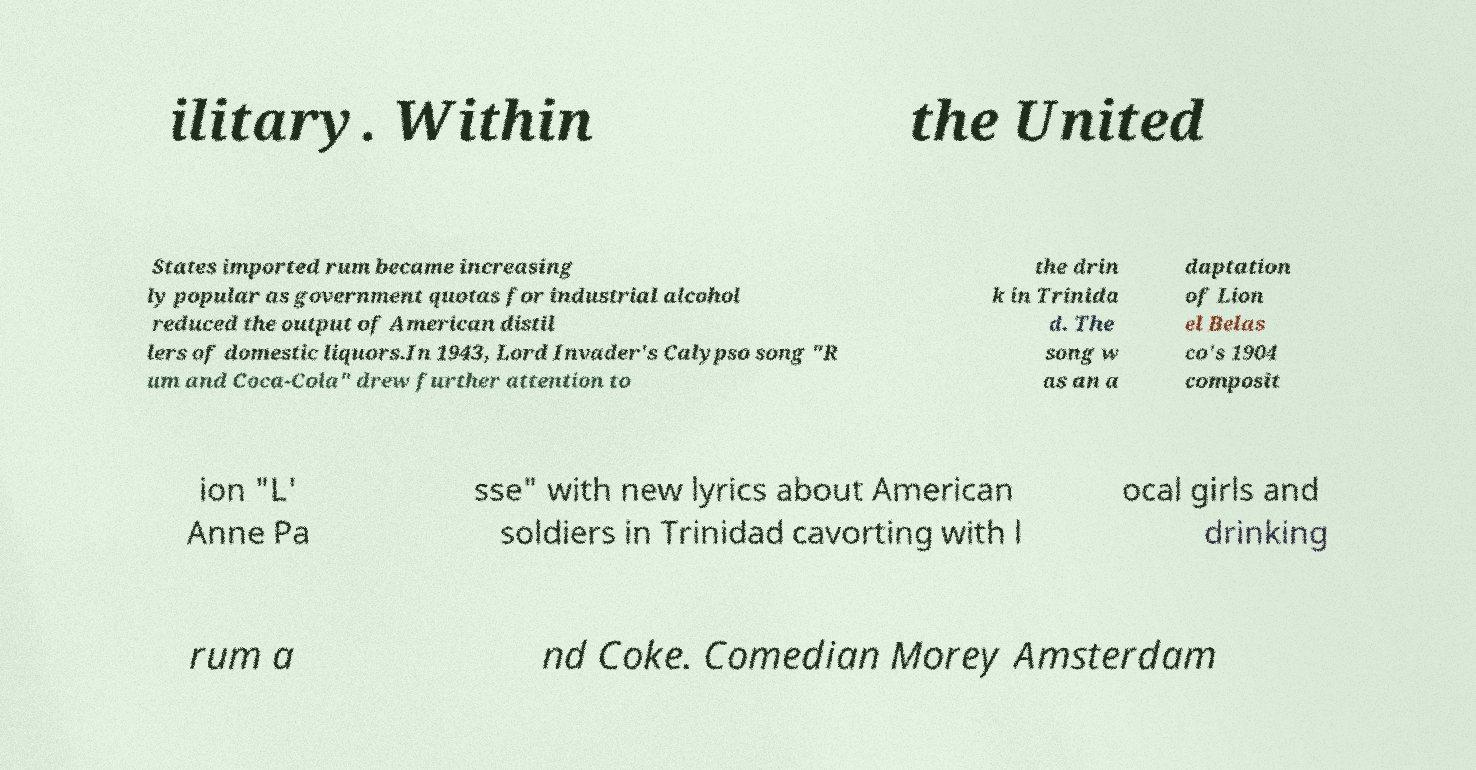Could you extract and type out the text from this image? ilitary. Within the United States imported rum became increasing ly popular as government quotas for industrial alcohol reduced the output of American distil lers of domestic liquors.In 1943, Lord Invader's Calypso song "R um and Coca-Cola" drew further attention to the drin k in Trinida d. The song w as an a daptation of Lion el Belas co's 1904 composit ion "L' Anne Pa sse" with new lyrics about American soldiers in Trinidad cavorting with l ocal girls and drinking rum a nd Coke. Comedian Morey Amsterdam 